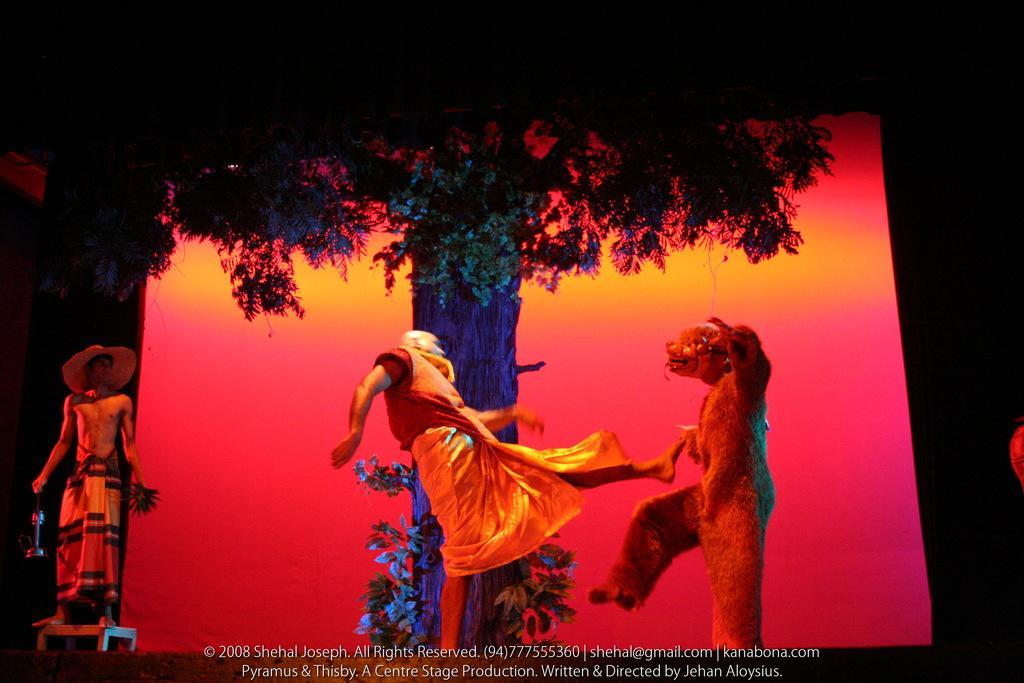Could you give a brief overview of what you see in this image? In this picture I can see a tree and a human standing on the side and another woman wore a bear mask and picture looks like a man might kicking bear mask man and i can see text at the bottom of the picture. 